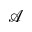<formula> <loc_0><loc_0><loc_500><loc_500>\mathcal { A }</formula> 